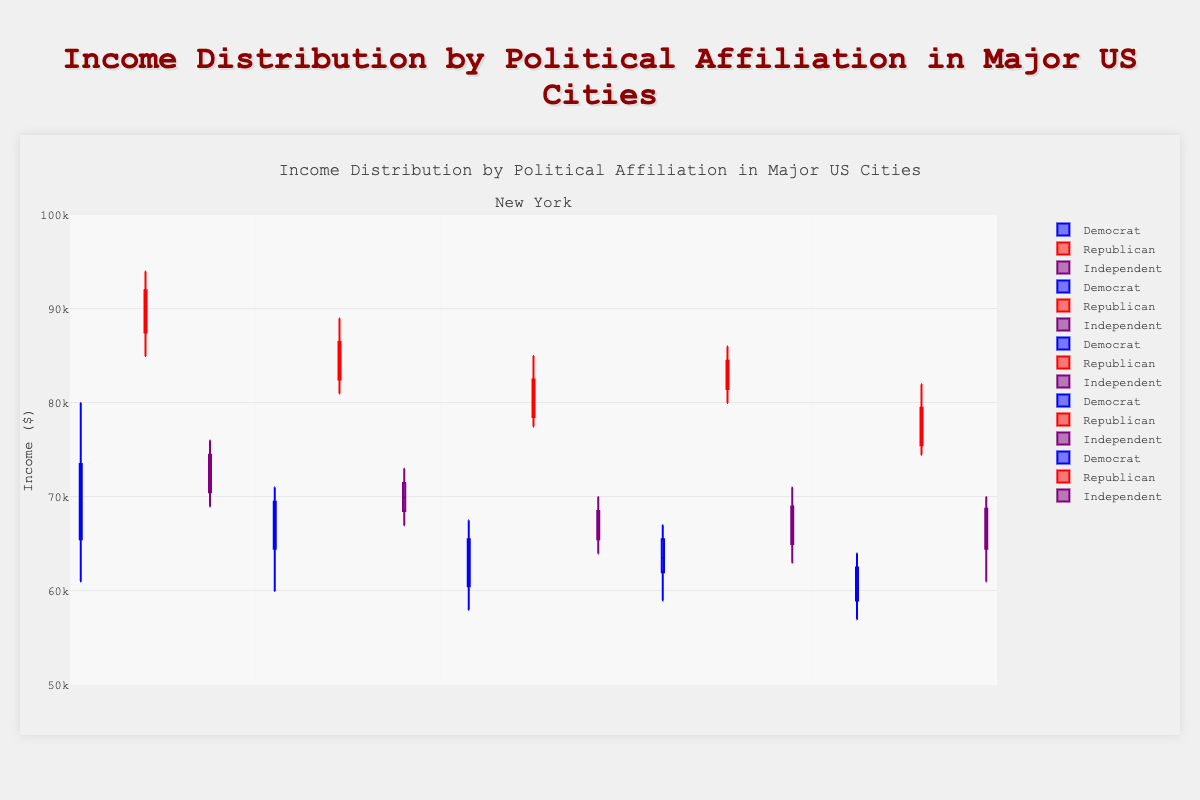What is the title of the chart? The title of the chart is usually displayed at the top center of the figure. By reading the text, we can find the title.
Answer: Income Distribution by Political Affiliation in Major US Cities How many cities are represented in the chart? By observing the number of different sections or groups along the x-axis, each representing a city, we can count the total number.
Answer: 5 Which political affiliation in New York has the highest median income? Look at the box plots for New York and identify the box plot with the highest line within the box (the median line).
Answer: Republican What is the range (difference between the highest and lowest values) of income for Democrats in Houston? Identify the box plot for Democrats in Houston. The highest value can be observed as the top whisker and the lowest value as the bottom whisker. Calculate the difference between these two values.
Answer: 8000 Compare the median incomes of Independents in Los Angeles and Chicago. Which is higher? Locate the box plots for Independents in both Los Angeles and Chicago. Observe the median line (middle line within the box) for both and compare their positions.
Answer: Chicago Are there any cities where Democrats have a higher median income than Independents? For each city, compare the median lines (middle line within the box) of Democrats and Independents' box plots. Determine if Democrats' median income is higher in any city.
Answer: No Which political affiliation tends to have the most income variation in Phoenix? Observe the length of the boxes and whiskers for each political affiliation in Phoenix. The longer the box and whiskers, the higher the variation.
Answer: Republican Do Independents in Chicago have a higher upper quartile income than Republicans in Phoenix? Compare the position of the top line of the box (upper quartile) for Independents in Chicago with the corresponding line for Republicans in Phoenix.
Answer: Yes What is the difference in median income between Democrats and Republicans in New York? Identify the median lines (middle line within the box) for both Democrats and Republicans in New York. Subtract the Democrats' median from the Republicans' median.
Answer: 20000 Which city shows the lowest median income for Republicans? Compare the median lines (middle line within the box) of Republicans' box plots across all cities and identify the lowest.
Answer: Phoenix 